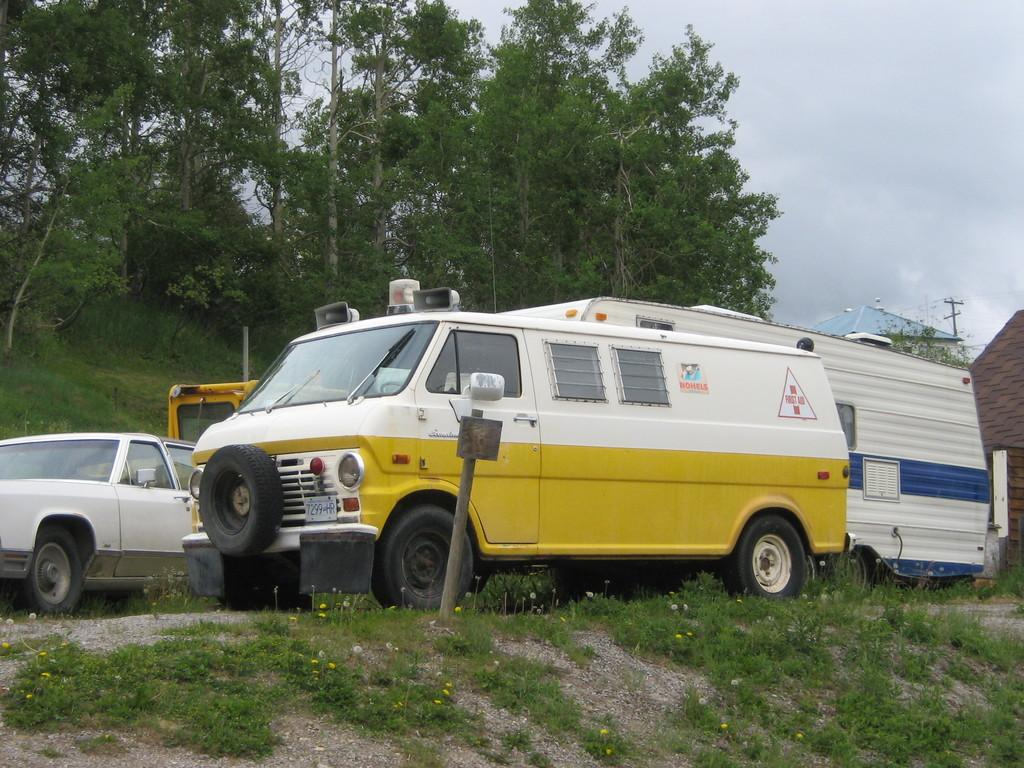What types of objects are present in the image? There are vehicles in the image. What can be seen in the background of the image? In the background, there are plants, grass, trees, buildings, a pole, and the sky. Can you describe the natural elements visible in the image? The natural elements include plants, grass, trees, and the sky. Where is the honey stored in the image? There is no honey present in the image. Can you describe the kitty's behavior in the image? There is no kitty present in the image. 